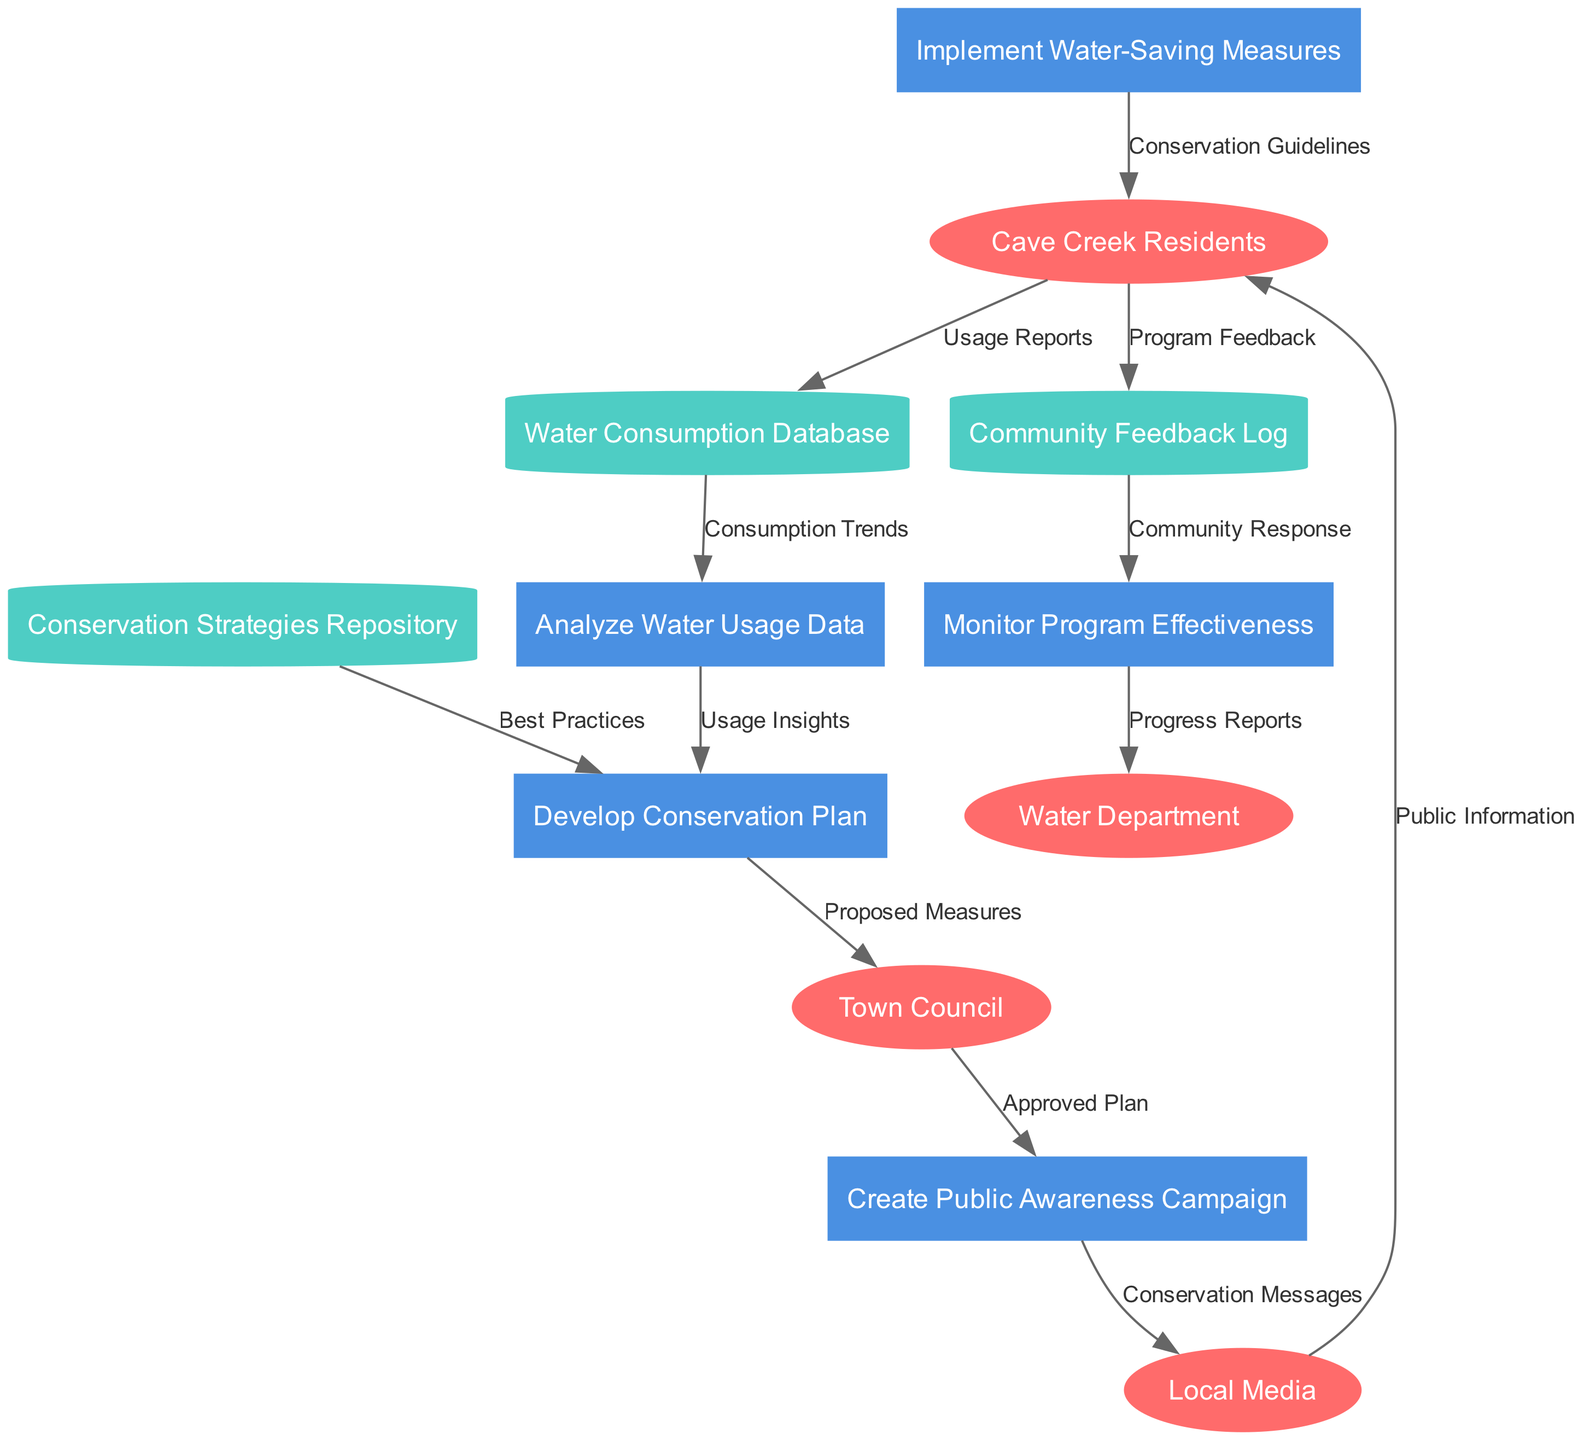What are the external entities in this diagram? The external entities are shown as ellipses in the diagram. They are: Cave Creek Residents, Town Council, Water Department, and Local Media.
Answer: Cave Creek Residents, Town Council, Water Department, Local Media How many processes are depicted in the diagram? Processes are represented by rectangles, and there are five of them listed: Analyze Water Usage Data, Develop Conservation Plan, Create Public Awareness Campaign, Implement Water-Saving Measures, and Monitor Program Effectiveness.
Answer: 5 What data flows from the Water Consumption Database to the Analyze Water Usage Data process? The data flow is labeled as "Consumption Trends", indicating what specific data is being utilized in the Analyze Water Usage Data process.
Answer: Consumption Trends Which entity provides the "Usage Reports"? The arrow labeled "Usage Reports" connects Cave Creek Residents to the Water Consumption Database, indicating that reports are submitted by this external entity.
Answer: Cave Creek Residents How many data stores are there in the diagram? The data stores are represented as cylinders, and there are three identified: Water Consumption Database, Conservation Strategies Repository, and Community Feedback Log.
Answer: 3 What feedback does the Community Feedback Log provide? The Community Feedback Log provides "Community Response" as indicated by the arrow leading into the Monitor Program Effectiveness process, showing the flow of data from the log.
Answer: Community Response What determines the content of the Create Public Awareness Campaign process? The content of the Create Public Awareness Campaign process is determined by the "Approved Plan" received from the Town Council, indicating a decision-making relationship between these two nodes.
Answer: Approved Plan What is the final destination of the progress reports generated in the Monitor Program Effectiveness process? The progress reports are sent to the Water Department, as indicated by the arrow leading from the Monitor Program Effectiveness process to the Water Department.
Answer: Water Department 